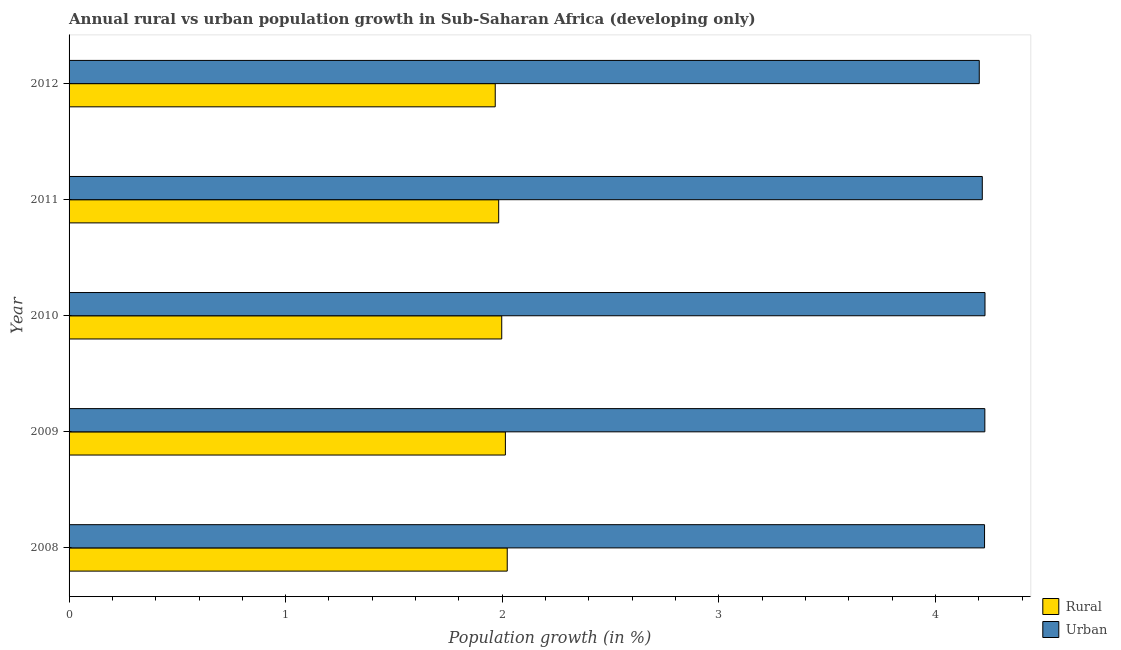How many different coloured bars are there?
Your response must be concise. 2. How many groups of bars are there?
Give a very brief answer. 5. Are the number of bars on each tick of the Y-axis equal?
Make the answer very short. Yes. How many bars are there on the 3rd tick from the bottom?
Make the answer very short. 2. In how many cases, is the number of bars for a given year not equal to the number of legend labels?
Make the answer very short. 0. What is the rural population growth in 2009?
Offer a terse response. 2.01. Across all years, what is the maximum urban population growth?
Your answer should be compact. 4.23. Across all years, what is the minimum rural population growth?
Keep it short and to the point. 1.97. What is the total rural population growth in the graph?
Provide a succinct answer. 9.99. What is the difference between the rural population growth in 2009 and that in 2010?
Offer a very short reply. 0.02. What is the difference between the urban population growth in 2010 and the rural population growth in 2012?
Make the answer very short. 2.26. What is the average urban population growth per year?
Offer a very short reply. 4.22. In the year 2010, what is the difference between the urban population growth and rural population growth?
Ensure brevity in your answer.  2.23. In how many years, is the urban population growth greater than 1.2 %?
Provide a short and direct response. 5. What is the difference between the highest and the second highest urban population growth?
Ensure brevity in your answer.  0. In how many years, is the rural population growth greater than the average rural population growth taken over all years?
Your response must be concise. 3. Is the sum of the urban population growth in 2008 and 2012 greater than the maximum rural population growth across all years?
Offer a terse response. Yes. What does the 1st bar from the top in 2009 represents?
Provide a short and direct response. Urban . What does the 2nd bar from the bottom in 2009 represents?
Provide a succinct answer. Urban . How many bars are there?
Provide a succinct answer. 10. Are all the bars in the graph horizontal?
Provide a succinct answer. Yes. Are the values on the major ticks of X-axis written in scientific E-notation?
Give a very brief answer. No. Does the graph contain any zero values?
Keep it short and to the point. No. How are the legend labels stacked?
Offer a very short reply. Vertical. What is the title of the graph?
Keep it short and to the point. Annual rural vs urban population growth in Sub-Saharan Africa (developing only). What is the label or title of the X-axis?
Your answer should be compact. Population growth (in %). What is the label or title of the Y-axis?
Your response must be concise. Year. What is the Population growth (in %) in Rural in 2008?
Your response must be concise. 2.02. What is the Population growth (in %) of Urban  in 2008?
Provide a succinct answer. 4.23. What is the Population growth (in %) of Rural in 2009?
Your response must be concise. 2.01. What is the Population growth (in %) of Urban  in 2009?
Your answer should be very brief. 4.23. What is the Population growth (in %) of Rural in 2010?
Offer a terse response. 2. What is the Population growth (in %) of Urban  in 2010?
Your answer should be very brief. 4.23. What is the Population growth (in %) of Rural in 2011?
Give a very brief answer. 1.98. What is the Population growth (in %) of Urban  in 2011?
Your answer should be compact. 4.22. What is the Population growth (in %) of Rural in 2012?
Keep it short and to the point. 1.97. What is the Population growth (in %) of Urban  in 2012?
Provide a succinct answer. 4.2. Across all years, what is the maximum Population growth (in %) in Rural?
Ensure brevity in your answer.  2.02. Across all years, what is the maximum Population growth (in %) in Urban ?
Your answer should be very brief. 4.23. Across all years, what is the minimum Population growth (in %) in Rural?
Offer a very short reply. 1.97. Across all years, what is the minimum Population growth (in %) in Urban ?
Give a very brief answer. 4.2. What is the total Population growth (in %) of Rural in the graph?
Your response must be concise. 9.99. What is the total Population growth (in %) of Urban  in the graph?
Make the answer very short. 21.1. What is the difference between the Population growth (in %) in Rural in 2008 and that in 2009?
Ensure brevity in your answer.  0.01. What is the difference between the Population growth (in %) in Urban  in 2008 and that in 2009?
Your answer should be compact. -0. What is the difference between the Population growth (in %) in Rural in 2008 and that in 2010?
Make the answer very short. 0.03. What is the difference between the Population growth (in %) in Urban  in 2008 and that in 2010?
Offer a very short reply. -0. What is the difference between the Population growth (in %) of Rural in 2008 and that in 2011?
Provide a short and direct response. 0.04. What is the difference between the Population growth (in %) in Urban  in 2008 and that in 2011?
Provide a short and direct response. 0.01. What is the difference between the Population growth (in %) in Rural in 2008 and that in 2012?
Your response must be concise. 0.06. What is the difference between the Population growth (in %) of Urban  in 2008 and that in 2012?
Offer a terse response. 0.02. What is the difference between the Population growth (in %) of Rural in 2009 and that in 2010?
Ensure brevity in your answer.  0.02. What is the difference between the Population growth (in %) of Urban  in 2009 and that in 2010?
Keep it short and to the point. -0. What is the difference between the Population growth (in %) of Rural in 2009 and that in 2011?
Your answer should be very brief. 0.03. What is the difference between the Population growth (in %) of Urban  in 2009 and that in 2011?
Give a very brief answer. 0.01. What is the difference between the Population growth (in %) of Rural in 2009 and that in 2012?
Your answer should be very brief. 0.05. What is the difference between the Population growth (in %) in Urban  in 2009 and that in 2012?
Offer a terse response. 0.03. What is the difference between the Population growth (in %) in Rural in 2010 and that in 2011?
Your answer should be compact. 0.01. What is the difference between the Population growth (in %) of Urban  in 2010 and that in 2011?
Your answer should be very brief. 0.01. What is the difference between the Population growth (in %) in Urban  in 2010 and that in 2012?
Your answer should be very brief. 0.03. What is the difference between the Population growth (in %) of Rural in 2011 and that in 2012?
Provide a short and direct response. 0.02. What is the difference between the Population growth (in %) in Urban  in 2011 and that in 2012?
Offer a very short reply. 0.01. What is the difference between the Population growth (in %) in Rural in 2008 and the Population growth (in %) in Urban  in 2009?
Ensure brevity in your answer.  -2.21. What is the difference between the Population growth (in %) of Rural in 2008 and the Population growth (in %) of Urban  in 2010?
Offer a very short reply. -2.21. What is the difference between the Population growth (in %) of Rural in 2008 and the Population growth (in %) of Urban  in 2011?
Offer a very short reply. -2.19. What is the difference between the Population growth (in %) of Rural in 2008 and the Population growth (in %) of Urban  in 2012?
Offer a very short reply. -2.18. What is the difference between the Population growth (in %) in Rural in 2009 and the Population growth (in %) in Urban  in 2010?
Provide a short and direct response. -2.21. What is the difference between the Population growth (in %) of Rural in 2009 and the Population growth (in %) of Urban  in 2011?
Provide a short and direct response. -2.2. What is the difference between the Population growth (in %) of Rural in 2009 and the Population growth (in %) of Urban  in 2012?
Ensure brevity in your answer.  -2.19. What is the difference between the Population growth (in %) in Rural in 2010 and the Population growth (in %) in Urban  in 2011?
Make the answer very short. -2.22. What is the difference between the Population growth (in %) of Rural in 2010 and the Population growth (in %) of Urban  in 2012?
Provide a succinct answer. -2.2. What is the difference between the Population growth (in %) of Rural in 2011 and the Population growth (in %) of Urban  in 2012?
Provide a short and direct response. -2.22. What is the average Population growth (in %) in Rural per year?
Your answer should be compact. 2. What is the average Population growth (in %) in Urban  per year?
Offer a very short reply. 4.22. In the year 2008, what is the difference between the Population growth (in %) of Rural and Population growth (in %) of Urban ?
Provide a succinct answer. -2.2. In the year 2009, what is the difference between the Population growth (in %) in Rural and Population growth (in %) in Urban ?
Offer a very short reply. -2.21. In the year 2010, what is the difference between the Population growth (in %) of Rural and Population growth (in %) of Urban ?
Your answer should be very brief. -2.23. In the year 2011, what is the difference between the Population growth (in %) in Rural and Population growth (in %) in Urban ?
Provide a short and direct response. -2.23. In the year 2012, what is the difference between the Population growth (in %) of Rural and Population growth (in %) of Urban ?
Ensure brevity in your answer.  -2.23. What is the ratio of the Population growth (in %) of Rural in 2008 to that in 2010?
Offer a terse response. 1.01. What is the ratio of the Population growth (in %) of Rural in 2008 to that in 2011?
Offer a terse response. 1.02. What is the ratio of the Population growth (in %) in Rural in 2008 to that in 2012?
Give a very brief answer. 1.03. What is the ratio of the Population growth (in %) of Urban  in 2008 to that in 2012?
Provide a succinct answer. 1.01. What is the ratio of the Population growth (in %) in Rural in 2009 to that in 2010?
Ensure brevity in your answer.  1.01. What is the ratio of the Population growth (in %) of Urban  in 2009 to that in 2010?
Ensure brevity in your answer.  1. What is the ratio of the Population growth (in %) of Rural in 2009 to that in 2011?
Make the answer very short. 1.02. What is the ratio of the Population growth (in %) of Rural in 2009 to that in 2012?
Ensure brevity in your answer.  1.02. What is the ratio of the Population growth (in %) in Urban  in 2009 to that in 2012?
Provide a short and direct response. 1.01. What is the ratio of the Population growth (in %) of Rural in 2010 to that in 2011?
Your response must be concise. 1.01. What is the ratio of the Population growth (in %) of Urban  in 2010 to that in 2011?
Offer a terse response. 1. What is the ratio of the Population growth (in %) in Rural in 2010 to that in 2012?
Your answer should be very brief. 1.02. What is the ratio of the Population growth (in %) in Urban  in 2010 to that in 2012?
Make the answer very short. 1.01. What is the ratio of the Population growth (in %) in Rural in 2011 to that in 2012?
Offer a terse response. 1.01. What is the difference between the highest and the second highest Population growth (in %) in Rural?
Make the answer very short. 0.01. What is the difference between the highest and the second highest Population growth (in %) in Urban ?
Your answer should be very brief. 0. What is the difference between the highest and the lowest Population growth (in %) of Rural?
Provide a short and direct response. 0.06. What is the difference between the highest and the lowest Population growth (in %) of Urban ?
Offer a terse response. 0.03. 